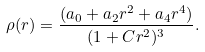<formula> <loc_0><loc_0><loc_500><loc_500>\rho ( r ) = \frac { ( a _ { 0 } + a _ { 2 } r ^ { 2 } + a _ { 4 } r ^ { 4 } ) } { ( 1 + C r ^ { 2 } ) ^ { 3 } } .</formula> 